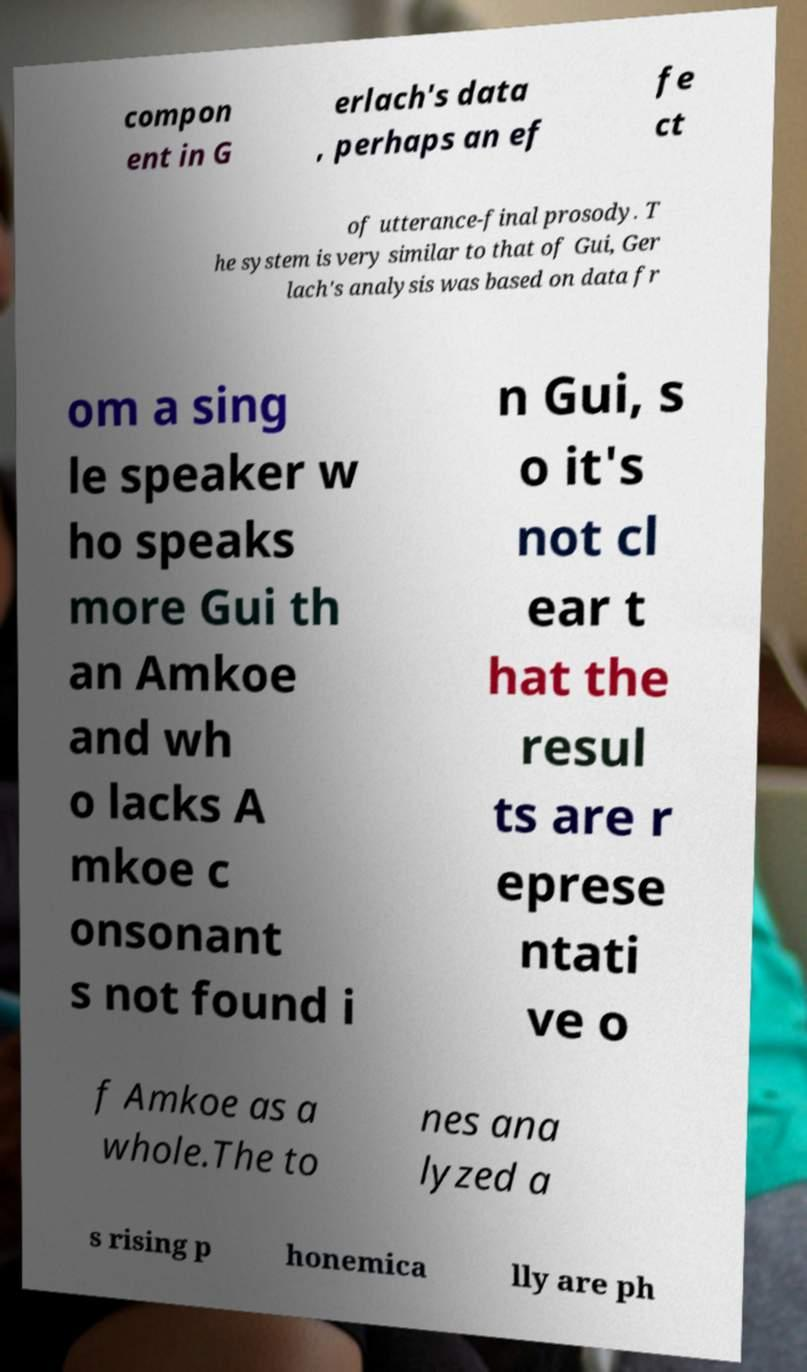There's text embedded in this image that I need extracted. Can you transcribe it verbatim? compon ent in G erlach's data , perhaps an ef fe ct of utterance-final prosody. T he system is very similar to that of Gui, Ger lach's analysis was based on data fr om a sing le speaker w ho speaks more Gui th an Amkoe and wh o lacks A mkoe c onsonant s not found i n Gui, s o it's not cl ear t hat the resul ts are r eprese ntati ve o f Amkoe as a whole.The to nes ana lyzed a s rising p honemica lly are ph 